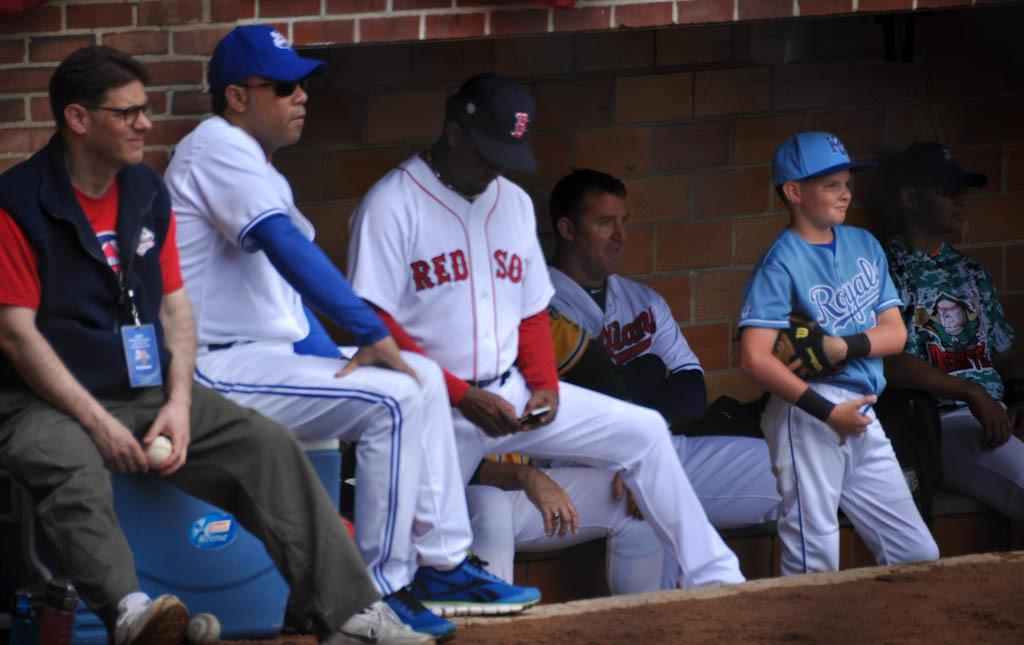<image>
Present a compact description of the photo's key features. A red sox baseball player is looking at his phone while he is standing near other people. 